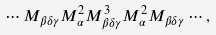Convert formula to latex. <formula><loc_0><loc_0><loc_500><loc_500>\cdots M _ { \beta \delta \gamma } M _ { \alpha } ^ { 2 } M _ { \beta \delta \gamma } ^ { 3 } M _ { \alpha } ^ { 2 } M _ { \beta \delta \gamma } \cdots ,</formula> 